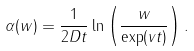<formula> <loc_0><loc_0><loc_500><loc_500>\alpha ( w ) = { \frac { 1 } { 2 D t } } \ln \left ( \frac { w } { \exp ( v t ) } \right ) .</formula> 